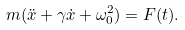Convert formula to latex. <formula><loc_0><loc_0><loc_500><loc_500>m ( \ddot { x } + \gamma \dot { x } + \omega ^ { 2 } _ { 0 } ) = F ( t ) .</formula> 